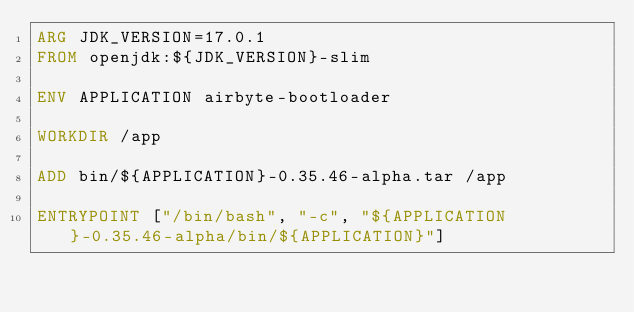<code> <loc_0><loc_0><loc_500><loc_500><_Dockerfile_>ARG JDK_VERSION=17.0.1
FROM openjdk:${JDK_VERSION}-slim

ENV APPLICATION airbyte-bootloader

WORKDIR /app

ADD bin/${APPLICATION}-0.35.46-alpha.tar /app

ENTRYPOINT ["/bin/bash", "-c", "${APPLICATION}-0.35.46-alpha/bin/${APPLICATION}"]
</code> 